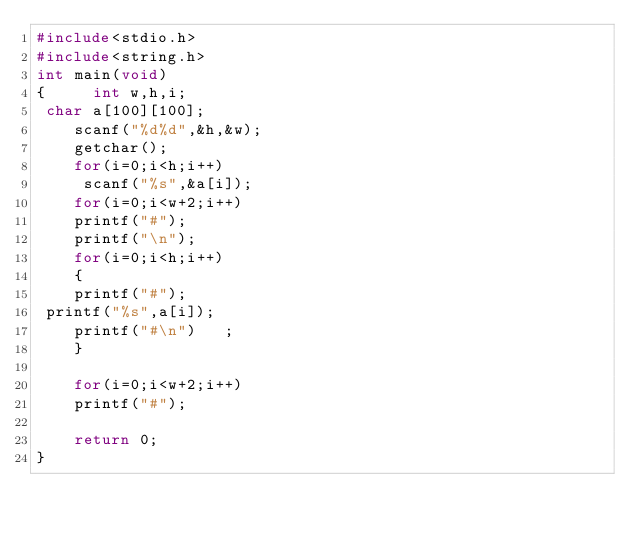<code> <loc_0><loc_0><loc_500><loc_500><_C_>#include<stdio.h>
#include<string.h>
int main(void) 
{     int w,h,i;
 char a[100][100];
    scanf("%d%d",&h,&w);
    getchar();
    for(i=0;i<h;i++)
     scanf("%s",&a[i]);
	for(i=0;i<w+2;i++)
	printf("#");
	printf("\n");
	for(i=0;i<h;i++)
	{
	printf("#");
 printf("%s",a[i]);
	printf("#\n")	;
	}
	
	for(i=0;i<w+2;i++)
	printf("#");
		
	return 0;
}</code> 